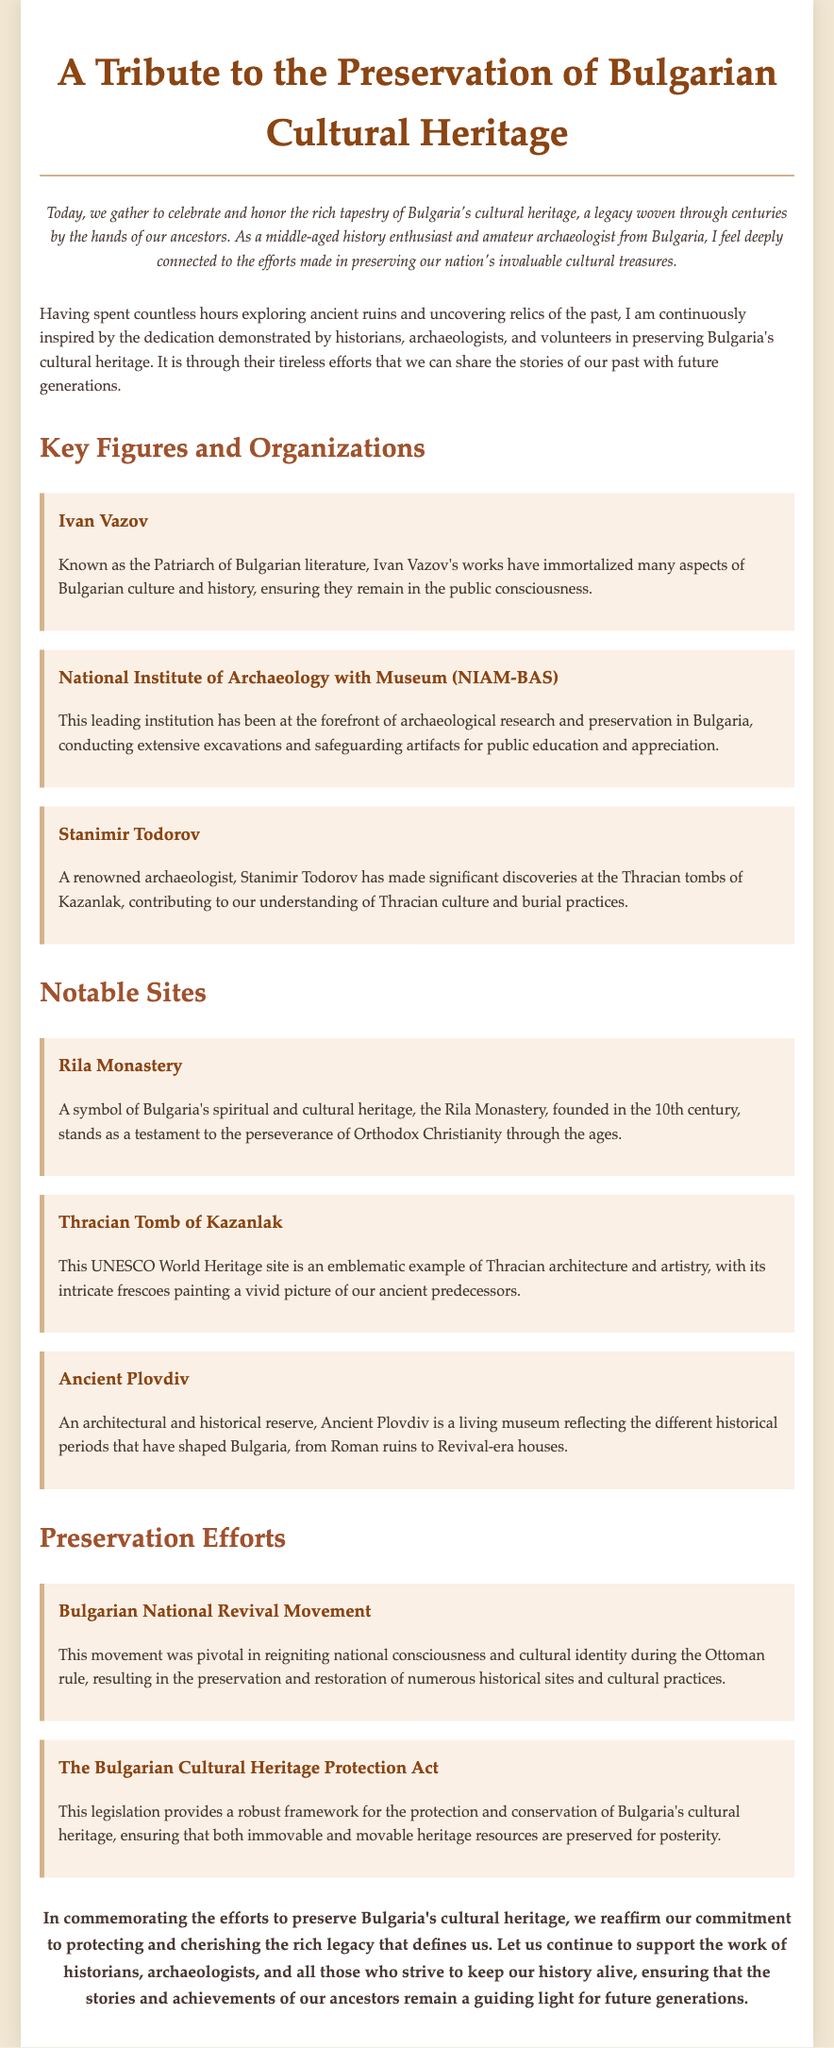What is celebrated in the eulogy? The eulogy celebrates the preservation of Bulgaria's cultural heritage.
Answer: Preservation of Bulgarian cultural heritage Who is known as the Patriarch of Bulgarian literature? Ivan Vazov is referred to as the Patriarch of Bulgarian literature in the document.
Answer: Ivan Vazov What notable site is a UNESCO World Heritage site? The document mentions the Thracian Tomb of Kazanlak as a UNESCO World Heritage site.
Answer: Thracian Tomb of Kazanlak Which organization is at the forefront of archaeological research in Bulgaria? The National Institute of Archaeology with Museum (NIAM-BAS) is highlighted as a leading institution.
Answer: National Institute of Archaeology with Museum (NIAM-BAS) What movement was pivotal during the Ottoman rule? The Bulgarian National Revival Movement is noted as pivotal in reigniting national consciousness.
Answer: Bulgarian National Revival Movement Which important legislation protects Bulgaria's cultural heritage? The Bulgarian Cultural Heritage Protection Act provides a framework for the protection of heritage.
Answer: Bulgarian Cultural Heritage Protection Act What is a key characteristic of the Rila Monastery? The Rila Monastery is described as a symbol of Bulgaria's spiritual and cultural heritage.
Answer: Symbol of spiritual and cultural heritage Who made significant discoveries at the Thracian tombs of Kazanlak? Stanimir Todorov is the renowned archaeologist mentioned in relation to the Thracian tombs.
Answer: Stanimir Todorov What is the purpose of the dedication mentioned in the eulogy? The dedication serves to honor the efforts of historians, archaeologists, and volunteers in preservation.
Answer: Honor the efforts of historians, archaeologists, and volunteers 